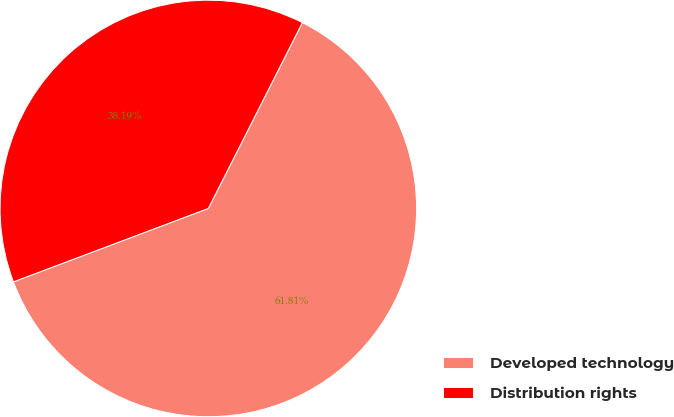<chart> <loc_0><loc_0><loc_500><loc_500><pie_chart><fcel>Developed technology<fcel>Distribution rights<nl><fcel>61.81%<fcel>38.19%<nl></chart> 